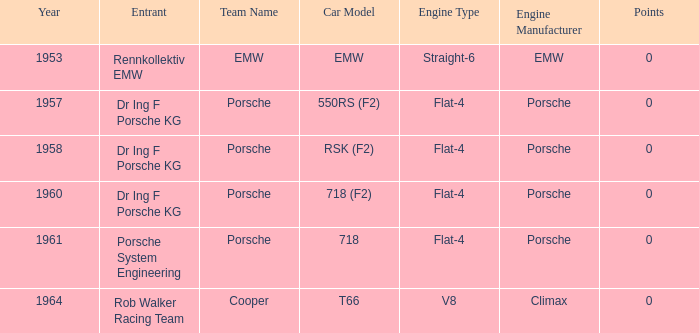Which engine did dr ing f porsche kg use with the porsche rsk (f2) chassis? Porsche Flat-4. 